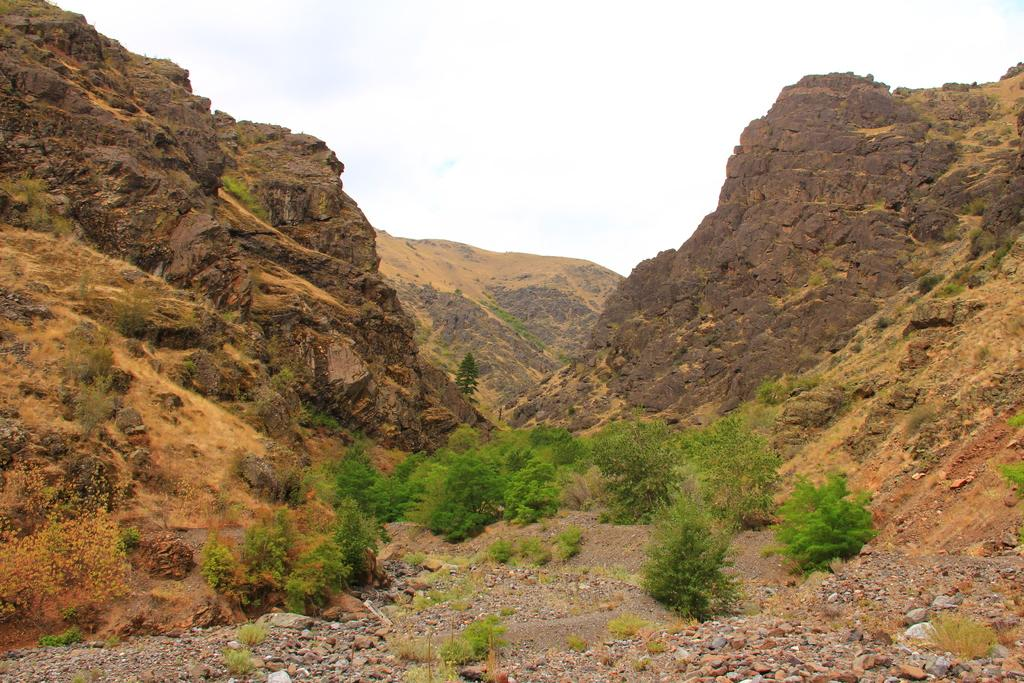What type of natural elements can be seen in the image? There are plants and mountains in the image. What is on the ground in the image? There are stones on the ground in the image. What can be seen in the background of the image? The sky is visible in the background of the image. What color is the paper used to write the description of the image? There is no paper or written description present in the image. 